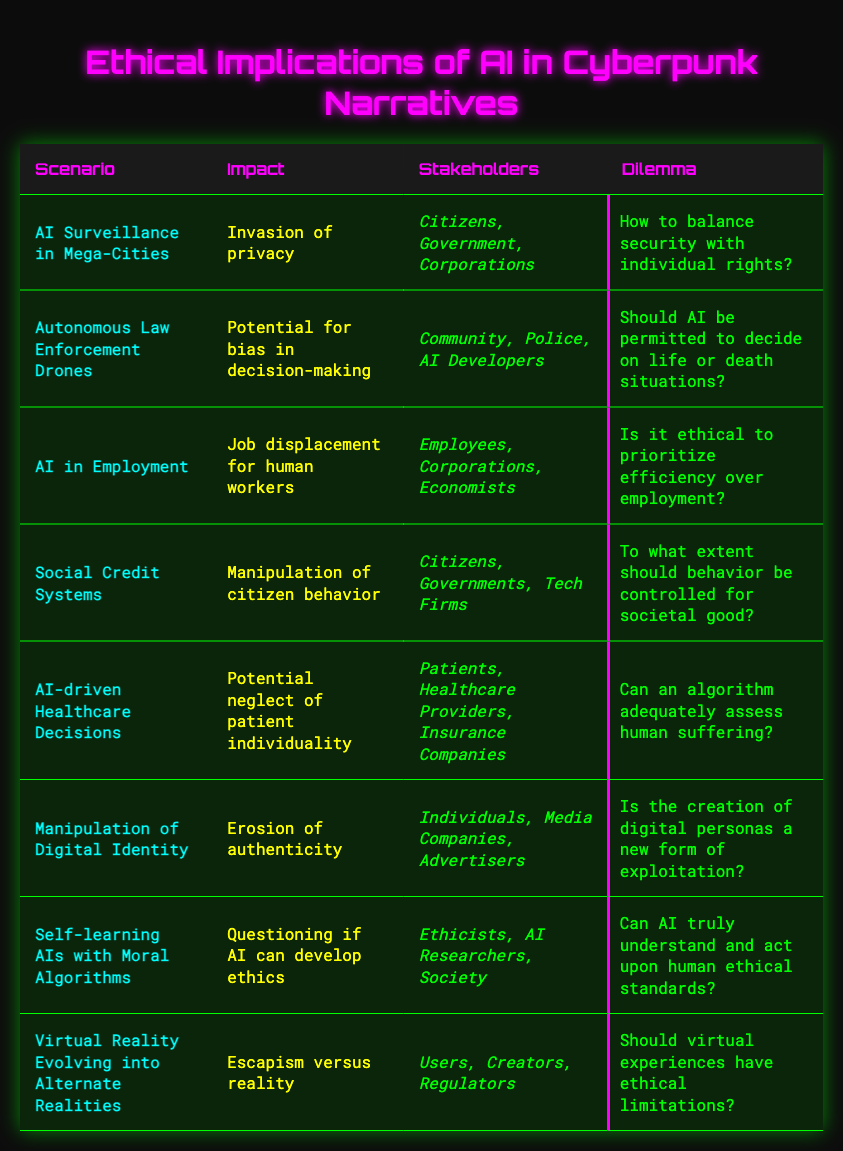What is the impact of AI Surveillance in Mega-Cities? The impact listed for this scenario in the table is "Invasion of privacy."
Answer: Invasion of privacy Who are the stakeholders involved in AI-driven Healthcare Decisions? The stakeholders listed in the table for this scenario include "Patients," "Healthcare Providers," and "Insurance Companies."
Answer: Patients, Healthcare Providers, Insurance Companies Is the creation of digital personas considered a form of exploitation? The dilemma for the manipulation of digital identity states, "Is the creation of digital personas a new form of exploitation?" This suggests that it raises the question of whether it is indeed exploitation, thus the answer is yes.
Answer: Yes How many scenarios mention citizens as stakeholders? By reviewing the table, "AI Surveillance in Mega-Cities," "Social Credit Systems," and "Manipulation of Digital Identity" all mention "Citizens" as stakeholders, totaling three scenarios.
Answer: 3 What is the main ethical dilemma associated with Social Credit Systems? The dilemma stated for Social Credit Systems is, "To what extent should behavior be controlled for societal good?" This outlines the ethical question raised.
Answer: To what extent should behavior be controlled for societal good? In how many scenarios is the potential for bias in decision-making highlighted? The table shows that only "Autonomous Law Enforcement Drones" mentions the "Potential for bias in decision-making." Thus, there is only one scenario that addresses this issue.
Answer: 1 Does AI in Employment prioritize efficiency over employment? The ethical dilemma posed states, "Is it ethical to prioritize efficiency over employment?" This implies that there is a debate surrounding the prioritization, suggesting a no.
Answer: No What is the impact of Self-learning AIs with Moral Algorithms? According to the table, the impact is "Questioning if AI can develop ethics," indicating concern about the ethical capabilities of AI.
Answer: Questioning if AI can develop ethics Which scenario involves the issue of escapism versus reality? The scenario "Virtual Reality Evolving into Alternate Realities" specifically states that escapism versus reality is a concern.
Answer: Virtual Reality Evolving into Alternate Realities 